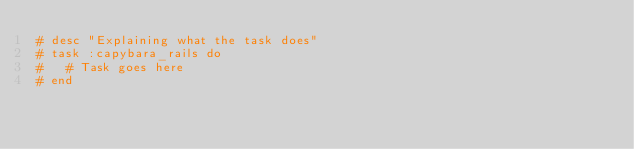<code> <loc_0><loc_0><loc_500><loc_500><_Ruby_># desc "Explaining what the task does"
# task :capybara_rails do
#   # Task goes here
# end
</code> 